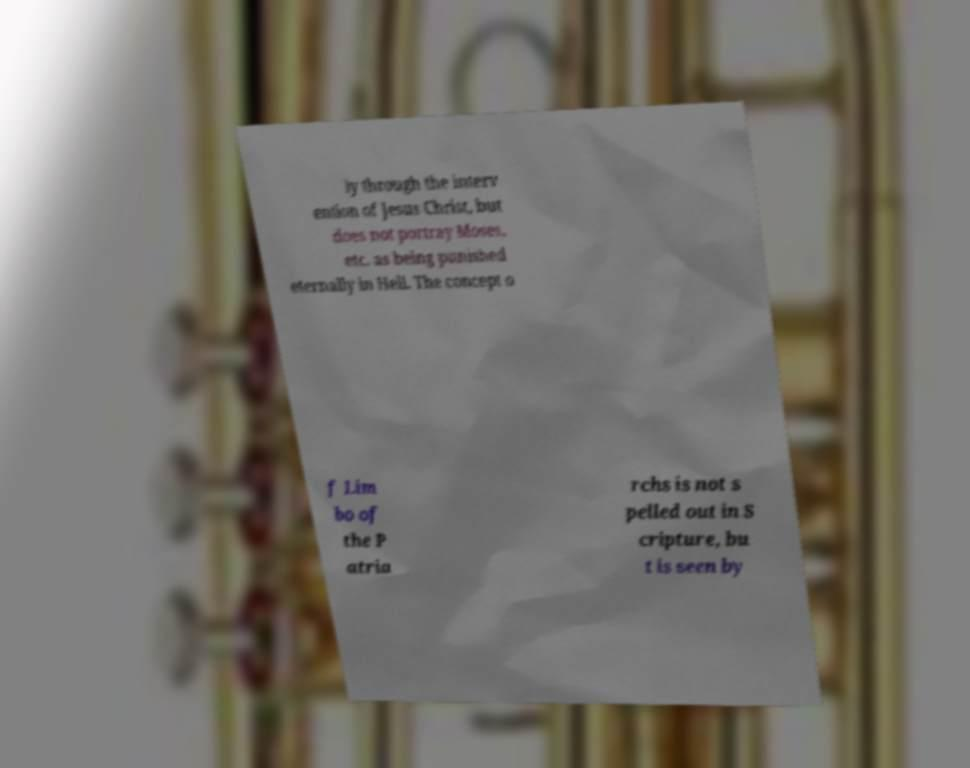Please identify and transcribe the text found in this image. ly through the interv ention of Jesus Christ, but does not portray Moses, etc. as being punished eternally in Hell. The concept o f Lim bo of the P atria rchs is not s pelled out in S cripture, bu t is seen by 